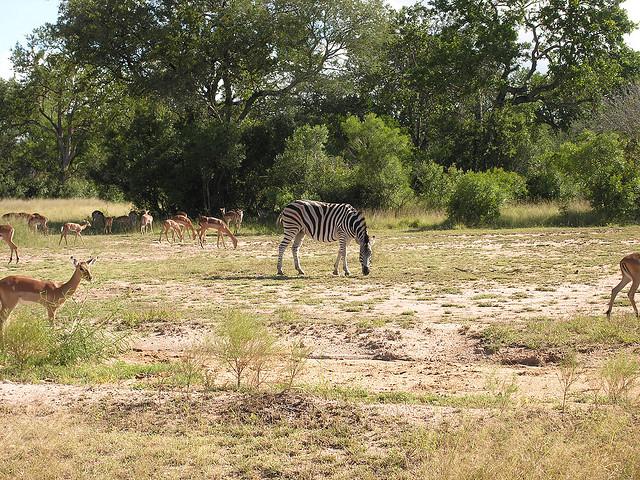What is behind the animals?
Short answer required. Trees. How many deer are on the field?
Write a very short answer. 12. How many zebra's?
Quick response, please. 1. 